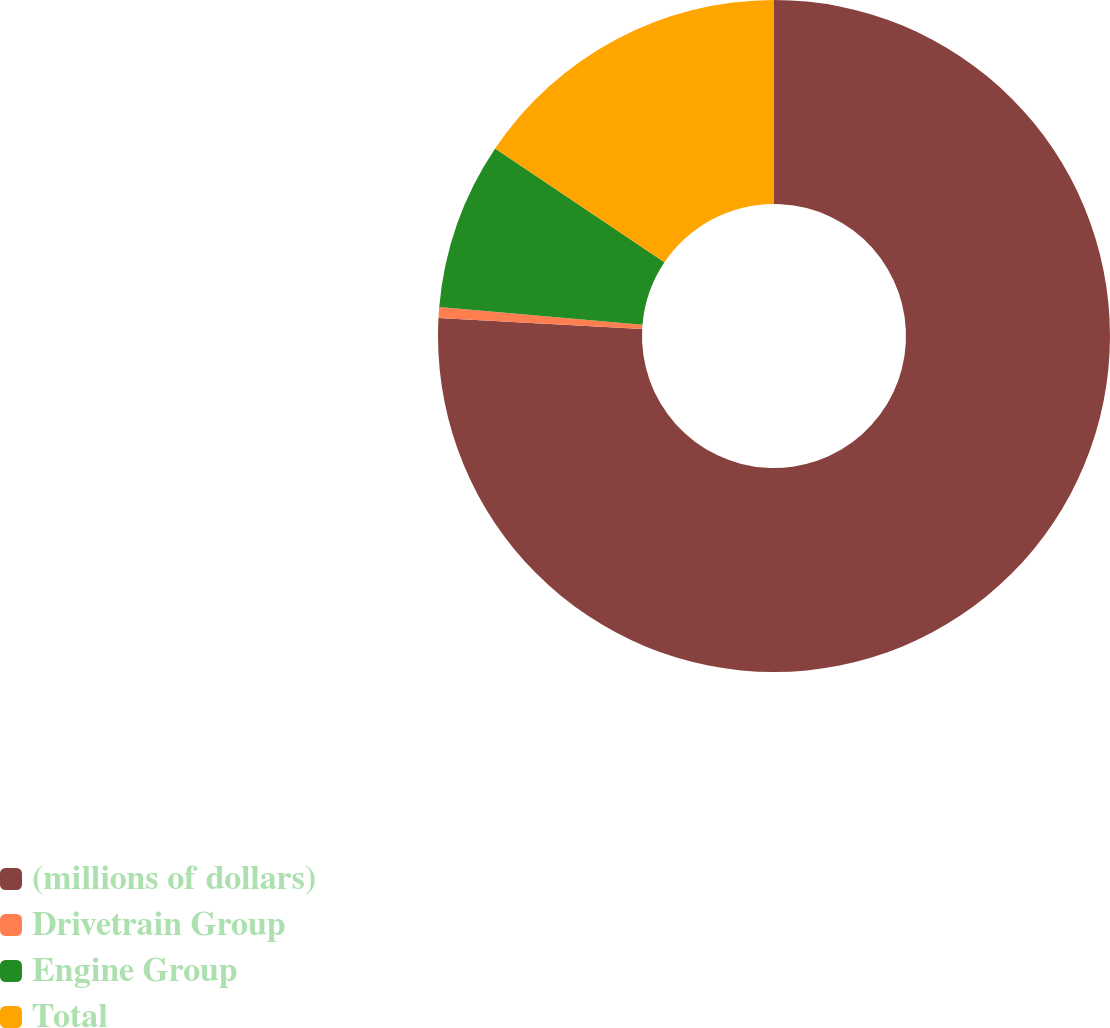<chart> <loc_0><loc_0><loc_500><loc_500><pie_chart><fcel>(millions of dollars)<fcel>Drivetrain Group<fcel>Engine Group<fcel>Total<nl><fcel>75.85%<fcel>0.52%<fcel>8.05%<fcel>15.58%<nl></chart> 